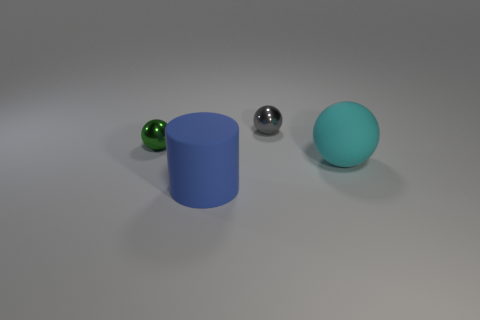What is the color of the small ball that is right of the green thing?
Your answer should be very brief. Gray. There is a sphere that is the same material as the big cylinder; what size is it?
Ensure brevity in your answer.  Large. There is a ball to the left of the rubber cylinder; what number of big blue rubber cylinders are on the right side of it?
Your answer should be very brief. 1. There is a large blue rubber thing; how many large things are behind it?
Make the answer very short. 1. What is the color of the metallic thing left of the big object on the left side of the ball that is in front of the tiny green shiny object?
Make the answer very short. Green. There is a tiny ball in front of the small gray thing; does it have the same color as the large thing that is on the left side of the tiny gray metallic ball?
Ensure brevity in your answer.  No. There is a tiny metallic object that is on the left side of the large object that is in front of the cyan matte sphere; what is its shape?
Your answer should be compact. Sphere. Is there a brown matte block that has the same size as the cyan rubber sphere?
Provide a short and direct response. No. How many small metallic things have the same shape as the blue rubber thing?
Offer a very short reply. 0. Are there the same number of big cylinders that are in front of the big blue cylinder and big cyan things to the left of the large cyan matte sphere?
Offer a very short reply. Yes. 